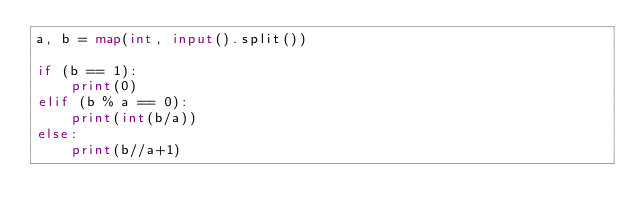<code> <loc_0><loc_0><loc_500><loc_500><_Python_>a, b = map(int, input().split())

if (b == 1):
    print(0)
elif (b % a == 0):
    print(int(b/a))
else:
    print(b//a+1)</code> 